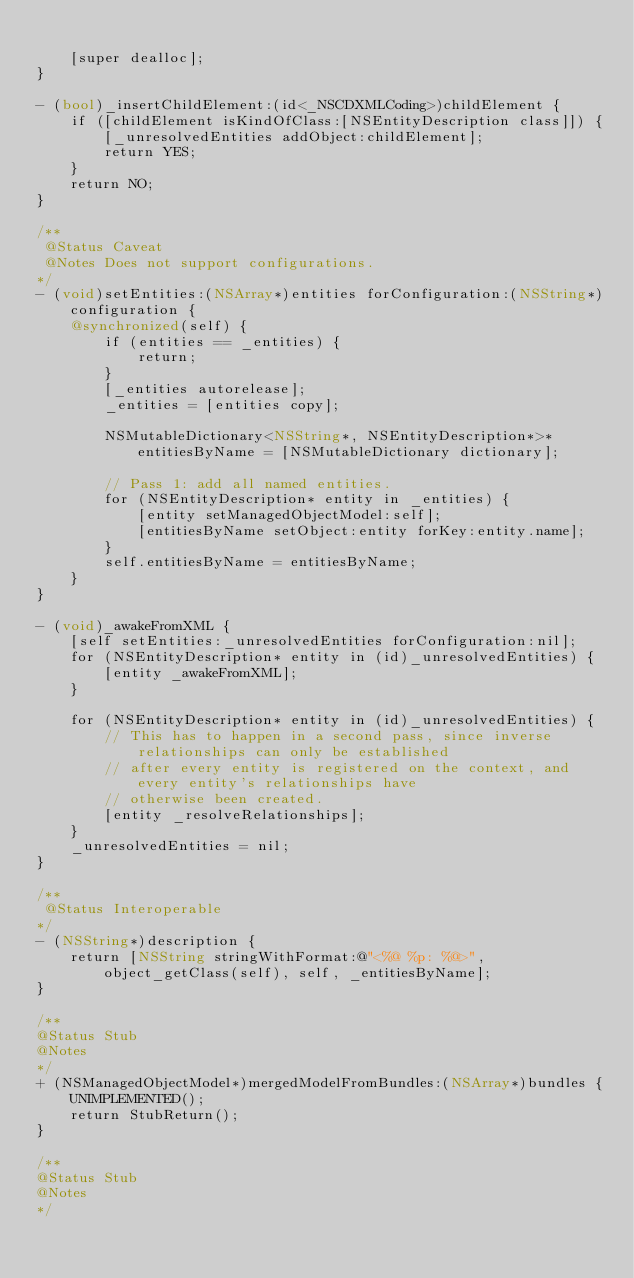Convert code to text. <code><loc_0><loc_0><loc_500><loc_500><_ObjectiveC_>
    [super dealloc];
}

- (bool)_insertChildElement:(id<_NSCDXMLCoding>)childElement {
    if ([childElement isKindOfClass:[NSEntityDescription class]]) {
        [_unresolvedEntities addObject:childElement];
        return YES;
    }
    return NO;
}

/**
 @Status Caveat
 @Notes Does not support configurations.
*/
- (void)setEntities:(NSArray*)entities forConfiguration:(NSString*)configuration {
    @synchronized(self) {
        if (entities == _entities) {
            return;
        }
        [_entities autorelease];
        _entities = [entities copy];

        NSMutableDictionary<NSString*, NSEntityDescription*>* entitiesByName = [NSMutableDictionary dictionary];

        // Pass 1: add all named entities.
        for (NSEntityDescription* entity in _entities) {
            [entity setManagedObjectModel:self];
            [entitiesByName setObject:entity forKey:entity.name];
        }
        self.entitiesByName = entitiesByName;
    }
}

- (void)_awakeFromXML {
    [self setEntities:_unresolvedEntities forConfiguration:nil];
    for (NSEntityDescription* entity in (id)_unresolvedEntities) {
        [entity _awakeFromXML];
    }

    for (NSEntityDescription* entity in (id)_unresolvedEntities) {
        // This has to happen in a second pass, since inverse relationships can only be established
        // after every entity is registered on the context, and every entity's relationships have
        // otherwise been created.
        [entity _resolveRelationships];
    }
    _unresolvedEntities = nil;
}

/**
 @Status Interoperable
*/
- (NSString*)description {
    return [NSString stringWithFormat:@"<%@ %p: %@>", object_getClass(self), self, _entitiesByName];
}

/**
@Status Stub
@Notes
*/
+ (NSManagedObjectModel*)mergedModelFromBundles:(NSArray*)bundles {
    UNIMPLEMENTED();
    return StubReturn();
}

/**
@Status Stub
@Notes
*/</code> 